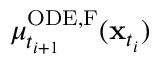<formula> <loc_0><loc_0><loc_500><loc_500>\mu _ { t _ { i + 1 } } ^ { O D E , F } ( x _ { t _ { i } } )</formula> 